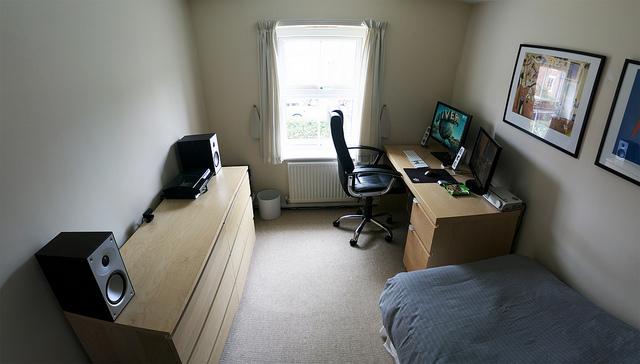What color is the desk on the right?
Short answer required. Brown. Is this a large space?
Keep it brief. No. How many pieces of framed artwork are on the wall?
Answer briefly. 2. 